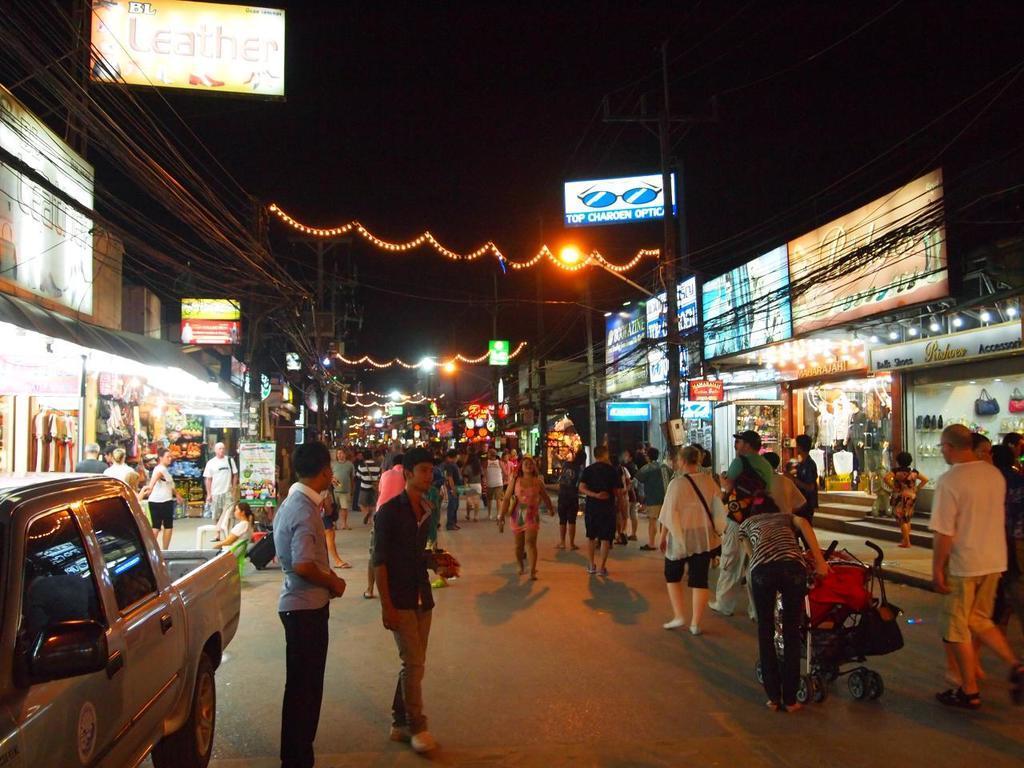In one or two sentences, can you explain what this image depicts? In this image I can see some people and vehicles on the road, beside them there are some shops. 